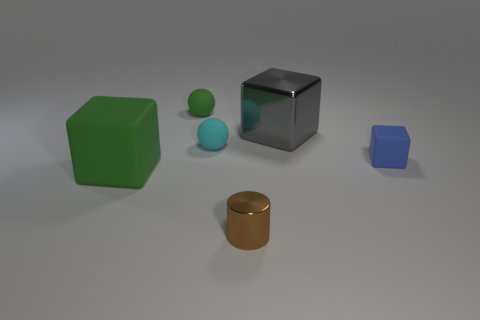Add 3 small yellow metal cubes. How many objects exist? 9 Subtract all spheres. How many objects are left? 4 Add 5 tiny red shiny spheres. How many tiny red shiny spheres exist? 5 Subtract 0 brown cubes. How many objects are left? 6 Subtract all red metal blocks. Subtract all brown metallic things. How many objects are left? 5 Add 3 small blue matte objects. How many small blue matte objects are left? 4 